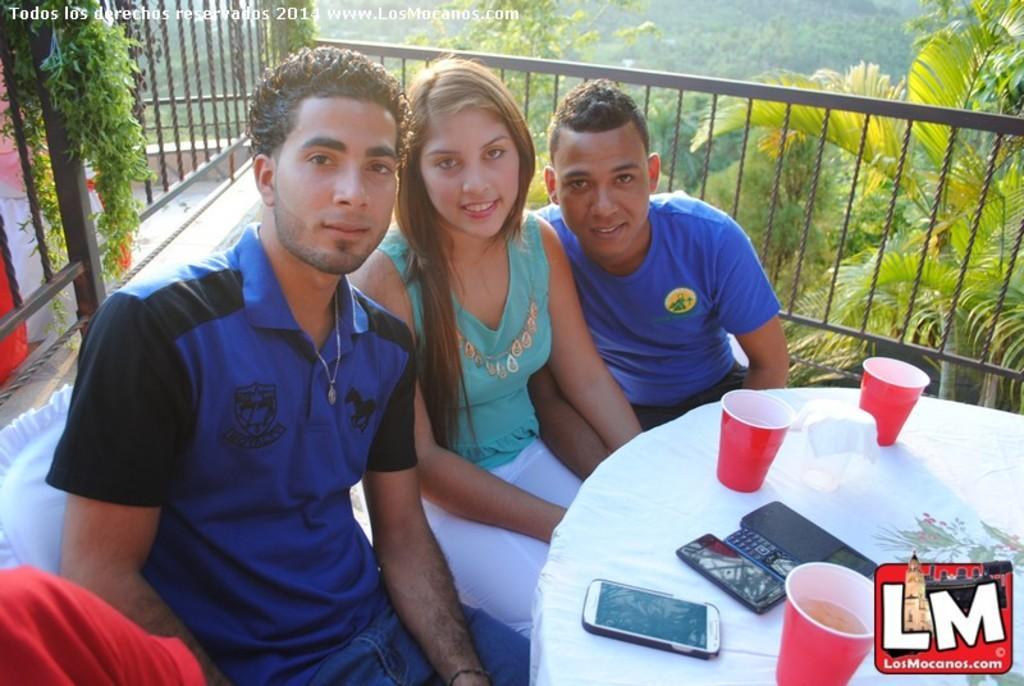Could you give a brief overview of what you see in this image? There are three people sitting in chairs and there is a white table in front of them which has mobile phones and a red cup on it and there are trees in the background. 